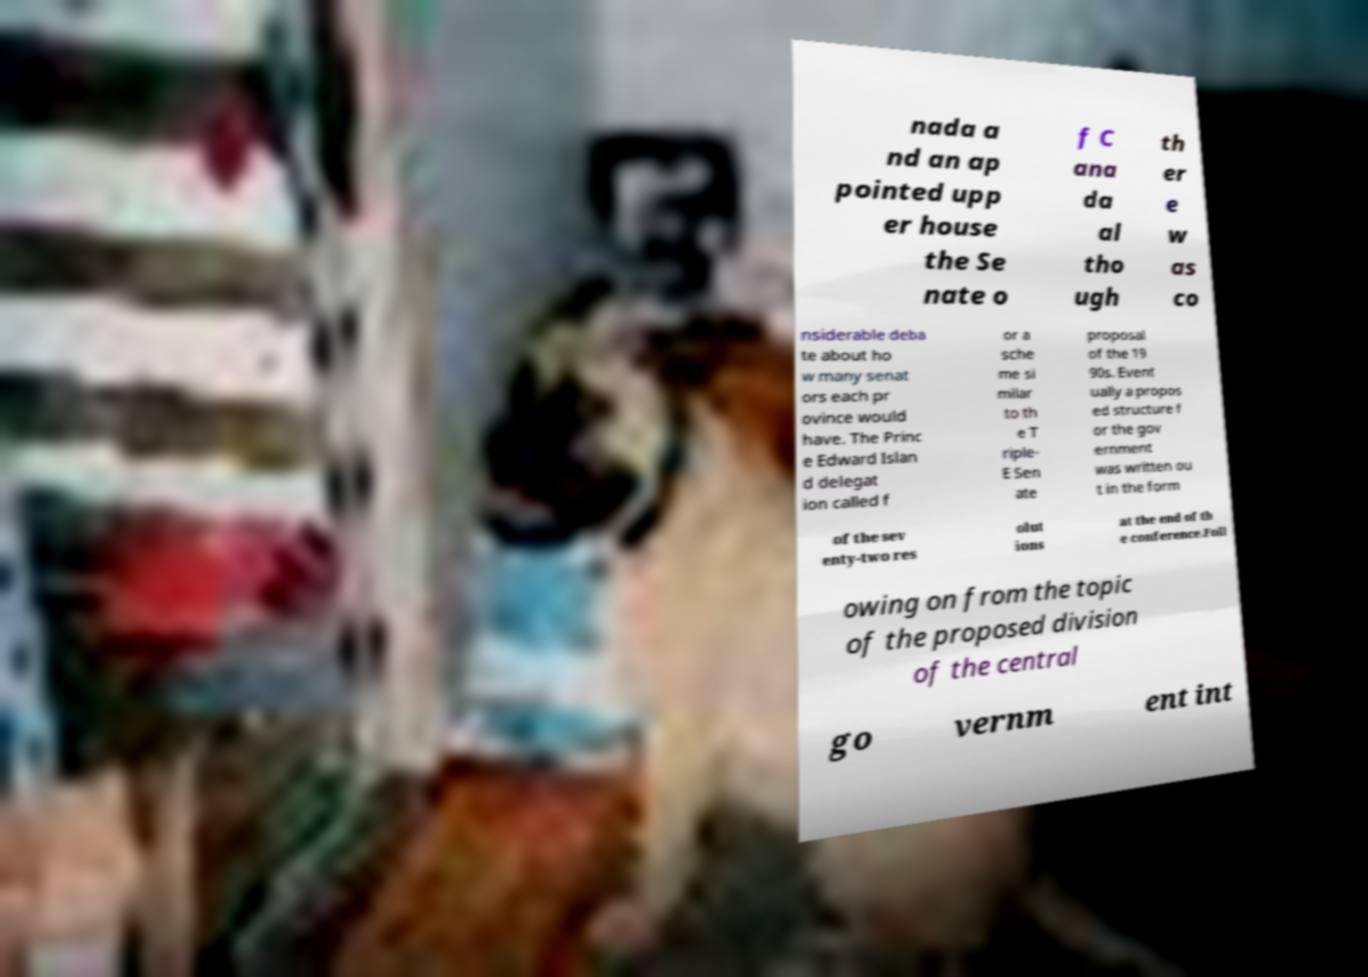There's text embedded in this image that I need extracted. Can you transcribe it verbatim? nada a nd an ap pointed upp er house the Se nate o f C ana da al tho ugh th er e w as co nsiderable deba te about ho w many senat ors each pr ovince would have. The Princ e Edward Islan d delegat ion called f or a sche me si milar to th e T riple- E Sen ate proposal of the 19 90s. Event ually a propos ed structure f or the gov ernment was written ou t in the form of the sev enty-two res olut ions at the end of th e conference.Foll owing on from the topic of the proposed division of the central go vernm ent int 